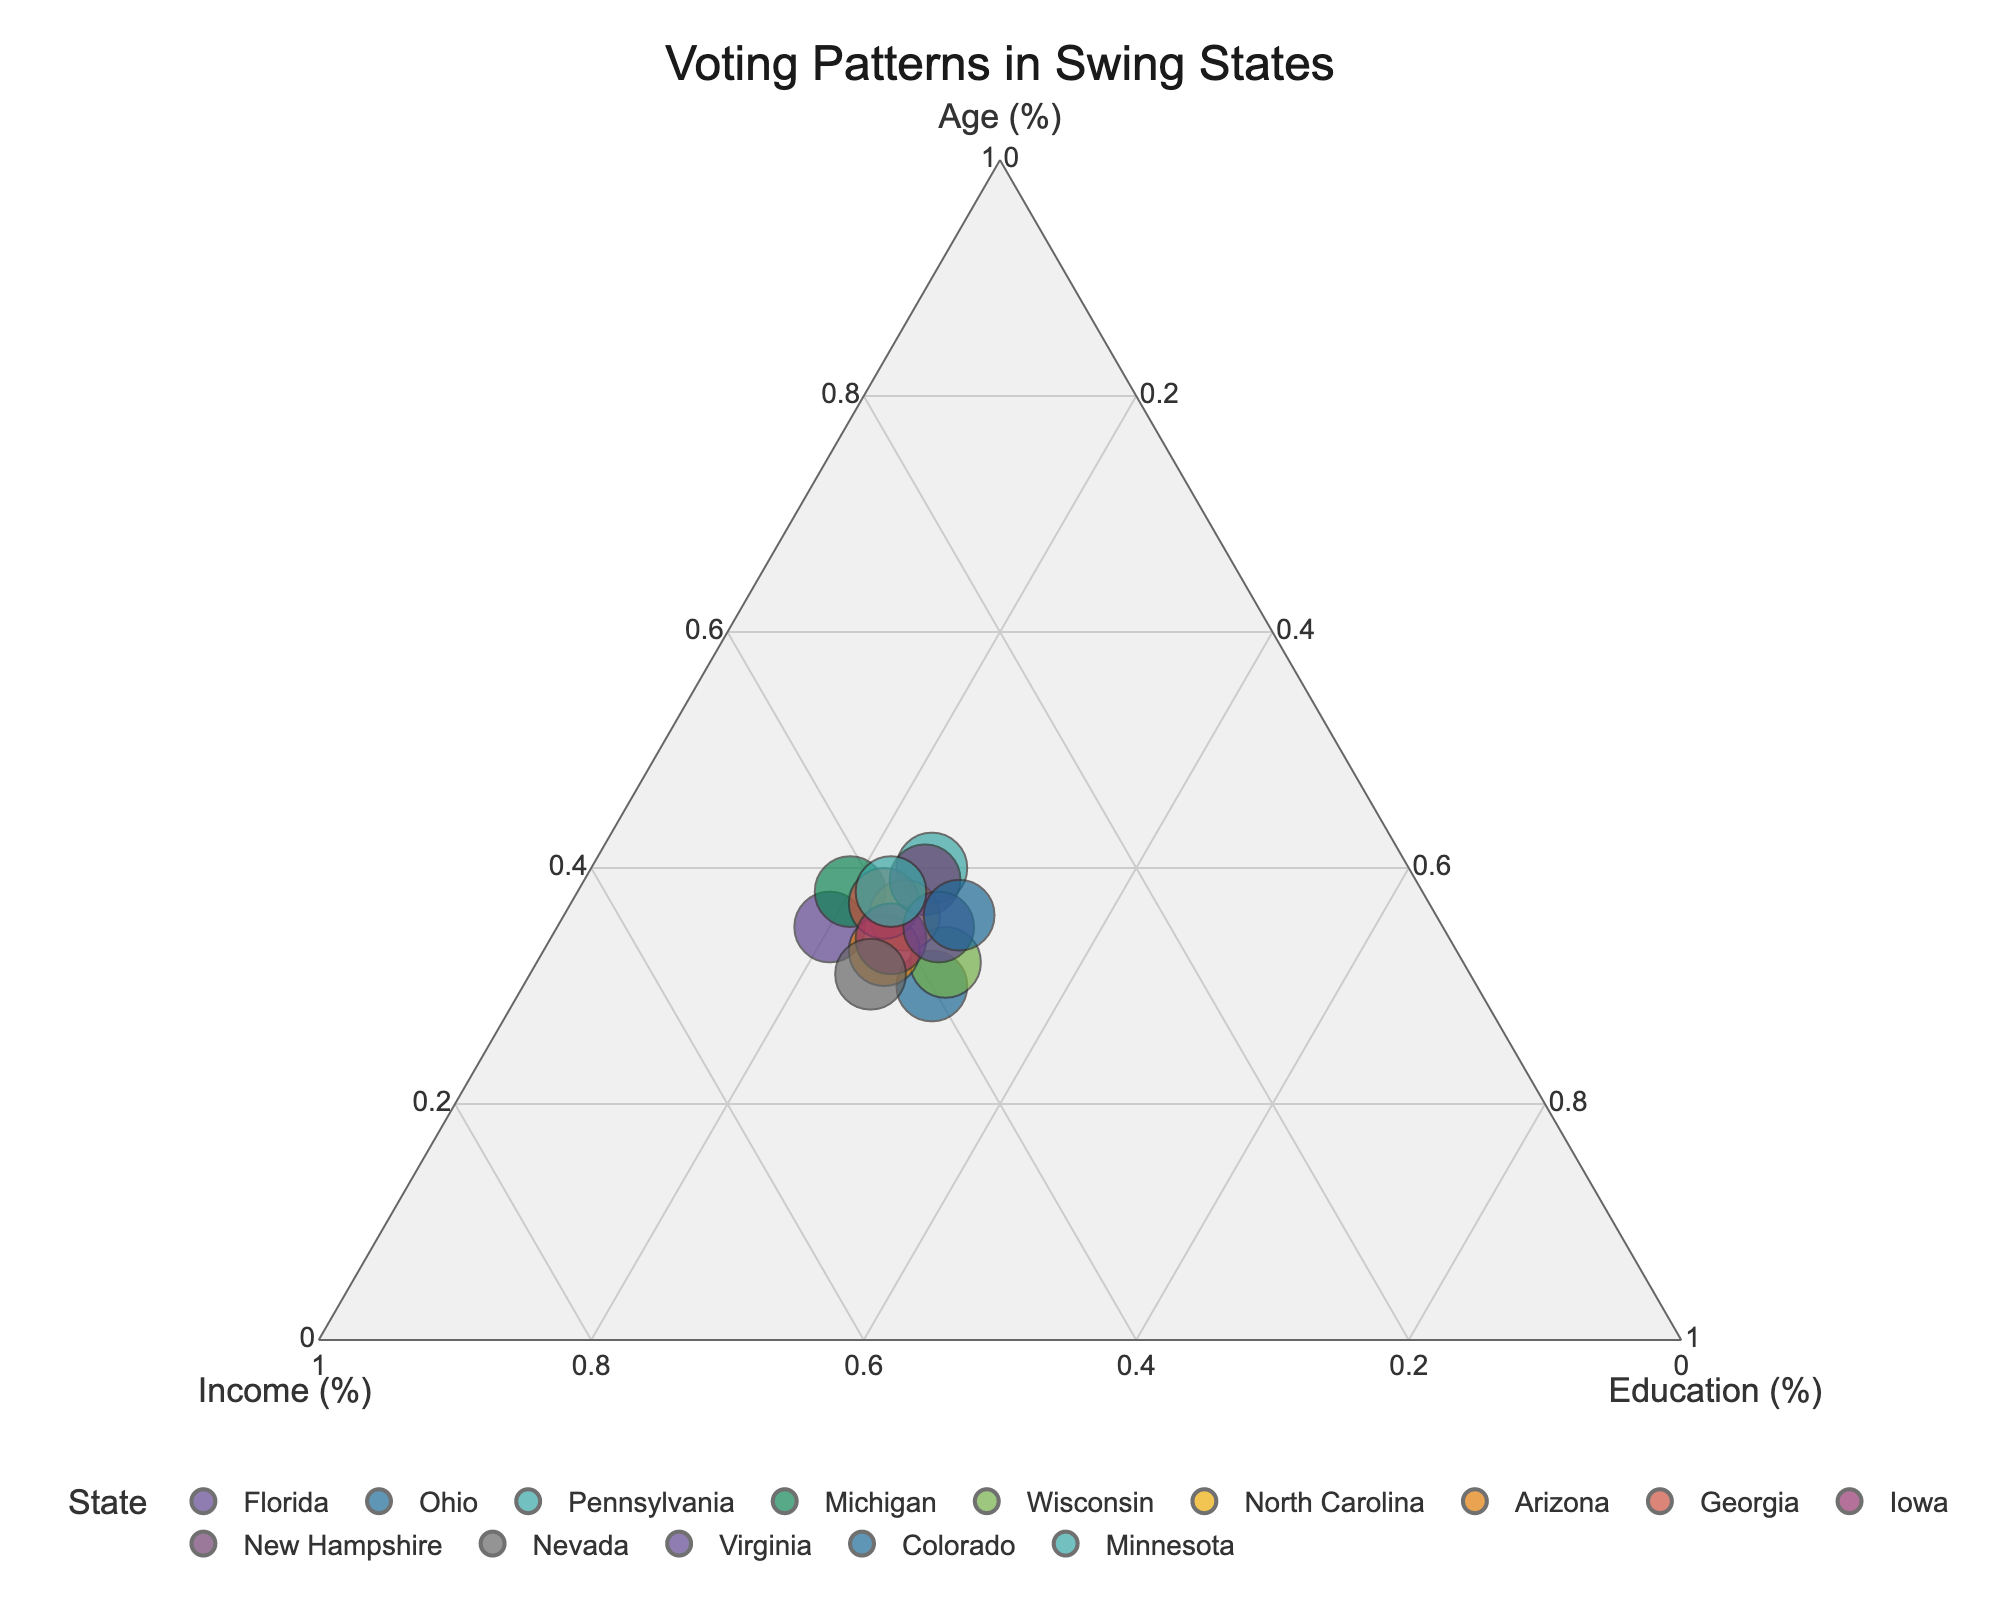What's the title of the figure? The title is usually placed at the top center of the figure and provides an overview of what the plot represents. From the given code, the title is explicitly set.
Answer: Voting Patterns in Swing States How many data points (states) are displayed in the plot? To find the number of data points, we count the states listed in the data table. Each state is represented by one data point.
Answer: 14 Which state has the highest percentage in the Education category? To identify the state with the highest Education percentage, locate the data point closest to the axis labeled "Education (%)" at the bottom of the ternary plot.
Answer: Ohio and Wisconsin What is the sum of the Age, Income, and Education percentages for Arizona? Add up the normalized values for Age, Income, and Education for Arizona. From the given normalization, the sum should be 100%.
Answer: 100% Which state has the largest marker on the plot and what does it represent? The size of the markers represents the 'Total' value (sum of Age, Income, and Education). The largest marker indicates the state with the highest total value.
Answer: Pennsylvania Compare the normalized values of Age and Income for Michigan. Which is higher? Locate Michigan on the ternary plot and compare the distances to the "Age (%)" and "Income (%)" axes. The axis nearer indicates a lower percentage.
Answer: Age Is there any state where the percentages of Age, Income, and Education are all equal? Check if any data point lies exactly at the center of the ternary plot where Age, Income, and Education would be 33.33% each.
Answer: No Which state lies closest to the point representing 40% Age, 40% Income, and 20% Education? Locate the point on the ternary plot where Age is 40%, Income is 40%, and Education is 20%, and find the nearest state data point.
Answer: Florida Identify the state with the lowest overall Education percentage. Locate the data point farthest from the "Education (%)" axis. This state has the lowest Education percentage.
Answer: Florida & Michigan Which state has a balanced composition with all three categories (Age, Income, Education) nearly equal? Identify a state whose data point lies near the center of the ternary plot where Age, Income, and Education are roughly equal.
Answer: Pennsylvania 